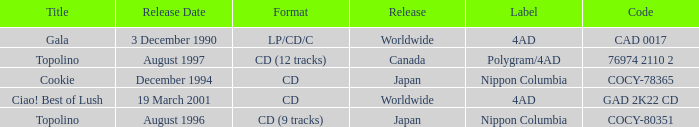What Label has a Code of cocy-78365? Nippon Columbia. 